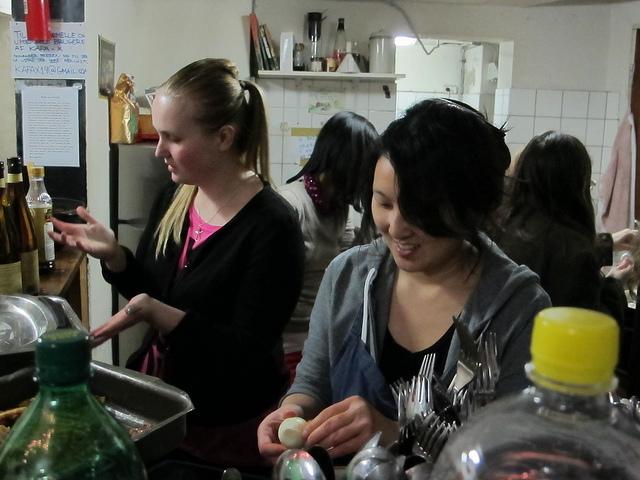How many colors of the rainbow are represented by the bottle tops at the front of the scene?
Be succinct. 2. What kind of utensils are in the lower left corner?
Short answer required. Forks. What is the girl closes to the camera peeling?
Write a very short answer. Egg. 